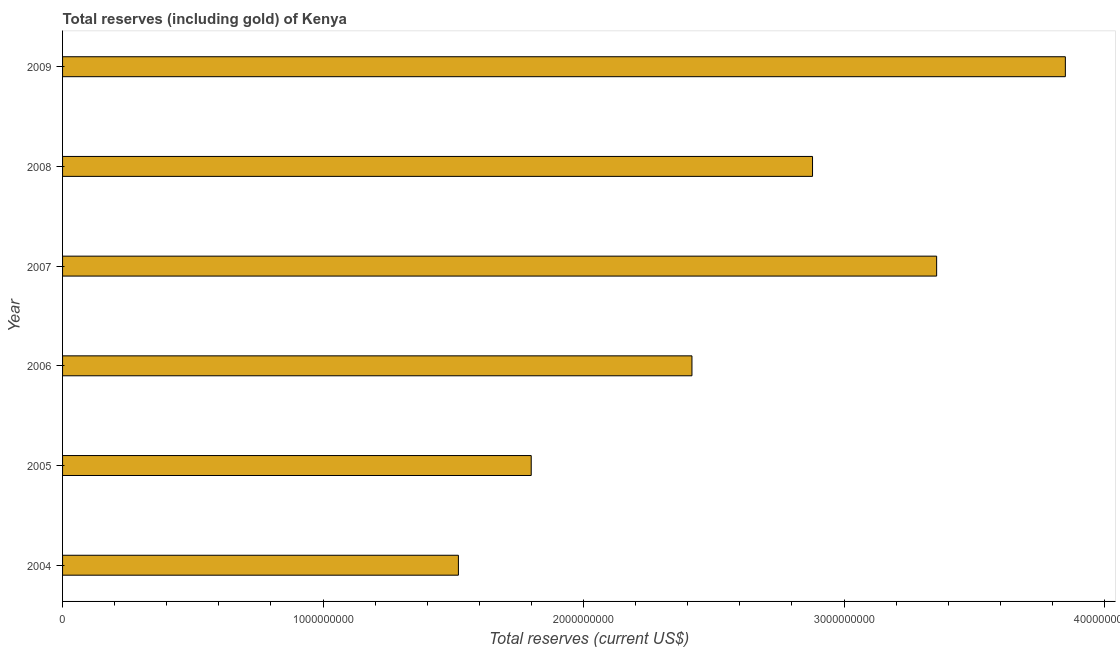Does the graph contain grids?
Offer a terse response. No. What is the title of the graph?
Your answer should be very brief. Total reserves (including gold) of Kenya. What is the label or title of the X-axis?
Keep it short and to the point. Total reserves (current US$). What is the total reserves (including gold) in 2007?
Your answer should be very brief. 3.36e+09. Across all years, what is the maximum total reserves (including gold)?
Your answer should be compact. 3.85e+09. Across all years, what is the minimum total reserves (including gold)?
Offer a very short reply. 1.52e+09. In which year was the total reserves (including gold) maximum?
Offer a very short reply. 2009. What is the sum of the total reserves (including gold)?
Keep it short and to the point. 1.58e+1. What is the difference between the total reserves (including gold) in 2004 and 2006?
Ensure brevity in your answer.  -8.97e+08. What is the average total reserves (including gold) per year?
Your response must be concise. 2.64e+09. What is the median total reserves (including gold)?
Provide a succinct answer. 2.65e+09. Do a majority of the years between 2008 and 2007 (inclusive) have total reserves (including gold) greater than 600000000 US$?
Give a very brief answer. No. What is the ratio of the total reserves (including gold) in 2006 to that in 2009?
Give a very brief answer. 0.63. What is the difference between the highest and the second highest total reserves (including gold)?
Give a very brief answer. 4.94e+08. What is the difference between the highest and the lowest total reserves (including gold)?
Ensure brevity in your answer.  2.33e+09. In how many years, is the total reserves (including gold) greater than the average total reserves (including gold) taken over all years?
Your answer should be very brief. 3. How many bars are there?
Your answer should be compact. 6. How many years are there in the graph?
Your answer should be very brief. 6. Are the values on the major ticks of X-axis written in scientific E-notation?
Provide a succinct answer. No. What is the Total reserves (current US$) in 2004?
Provide a succinct answer. 1.52e+09. What is the Total reserves (current US$) in 2005?
Give a very brief answer. 1.80e+09. What is the Total reserves (current US$) of 2006?
Provide a succinct answer. 2.42e+09. What is the Total reserves (current US$) of 2007?
Your answer should be very brief. 3.36e+09. What is the Total reserves (current US$) of 2008?
Keep it short and to the point. 2.88e+09. What is the Total reserves (current US$) in 2009?
Keep it short and to the point. 3.85e+09. What is the difference between the Total reserves (current US$) in 2004 and 2005?
Keep it short and to the point. -2.80e+08. What is the difference between the Total reserves (current US$) in 2004 and 2006?
Provide a short and direct response. -8.97e+08. What is the difference between the Total reserves (current US$) in 2004 and 2007?
Your response must be concise. -1.84e+09. What is the difference between the Total reserves (current US$) in 2004 and 2008?
Provide a short and direct response. -1.36e+09. What is the difference between the Total reserves (current US$) in 2004 and 2009?
Provide a short and direct response. -2.33e+09. What is the difference between the Total reserves (current US$) in 2005 and 2006?
Ensure brevity in your answer.  -6.17e+08. What is the difference between the Total reserves (current US$) in 2005 and 2007?
Give a very brief answer. -1.56e+09. What is the difference between the Total reserves (current US$) in 2005 and 2008?
Offer a very short reply. -1.08e+09. What is the difference between the Total reserves (current US$) in 2005 and 2009?
Offer a very short reply. -2.05e+09. What is the difference between the Total reserves (current US$) in 2006 and 2007?
Offer a very short reply. -9.39e+08. What is the difference between the Total reserves (current US$) in 2006 and 2008?
Your response must be concise. -4.63e+08. What is the difference between the Total reserves (current US$) in 2006 and 2009?
Give a very brief answer. -1.43e+09. What is the difference between the Total reserves (current US$) in 2007 and 2008?
Your answer should be compact. 4.76e+08. What is the difference between the Total reserves (current US$) in 2007 and 2009?
Your response must be concise. -4.94e+08. What is the difference between the Total reserves (current US$) in 2008 and 2009?
Give a very brief answer. -9.71e+08. What is the ratio of the Total reserves (current US$) in 2004 to that in 2005?
Offer a very short reply. 0.84. What is the ratio of the Total reserves (current US$) in 2004 to that in 2006?
Your response must be concise. 0.63. What is the ratio of the Total reserves (current US$) in 2004 to that in 2007?
Keep it short and to the point. 0.45. What is the ratio of the Total reserves (current US$) in 2004 to that in 2008?
Your answer should be very brief. 0.53. What is the ratio of the Total reserves (current US$) in 2004 to that in 2009?
Provide a succinct answer. 0.4. What is the ratio of the Total reserves (current US$) in 2005 to that in 2006?
Offer a very short reply. 0.74. What is the ratio of the Total reserves (current US$) in 2005 to that in 2007?
Your answer should be compact. 0.54. What is the ratio of the Total reserves (current US$) in 2005 to that in 2008?
Provide a succinct answer. 0.62. What is the ratio of the Total reserves (current US$) in 2005 to that in 2009?
Give a very brief answer. 0.47. What is the ratio of the Total reserves (current US$) in 2006 to that in 2007?
Your answer should be very brief. 0.72. What is the ratio of the Total reserves (current US$) in 2006 to that in 2008?
Provide a short and direct response. 0.84. What is the ratio of the Total reserves (current US$) in 2006 to that in 2009?
Provide a short and direct response. 0.63. What is the ratio of the Total reserves (current US$) in 2007 to that in 2008?
Make the answer very short. 1.17. What is the ratio of the Total reserves (current US$) in 2007 to that in 2009?
Your answer should be compact. 0.87. What is the ratio of the Total reserves (current US$) in 2008 to that in 2009?
Provide a short and direct response. 0.75. 